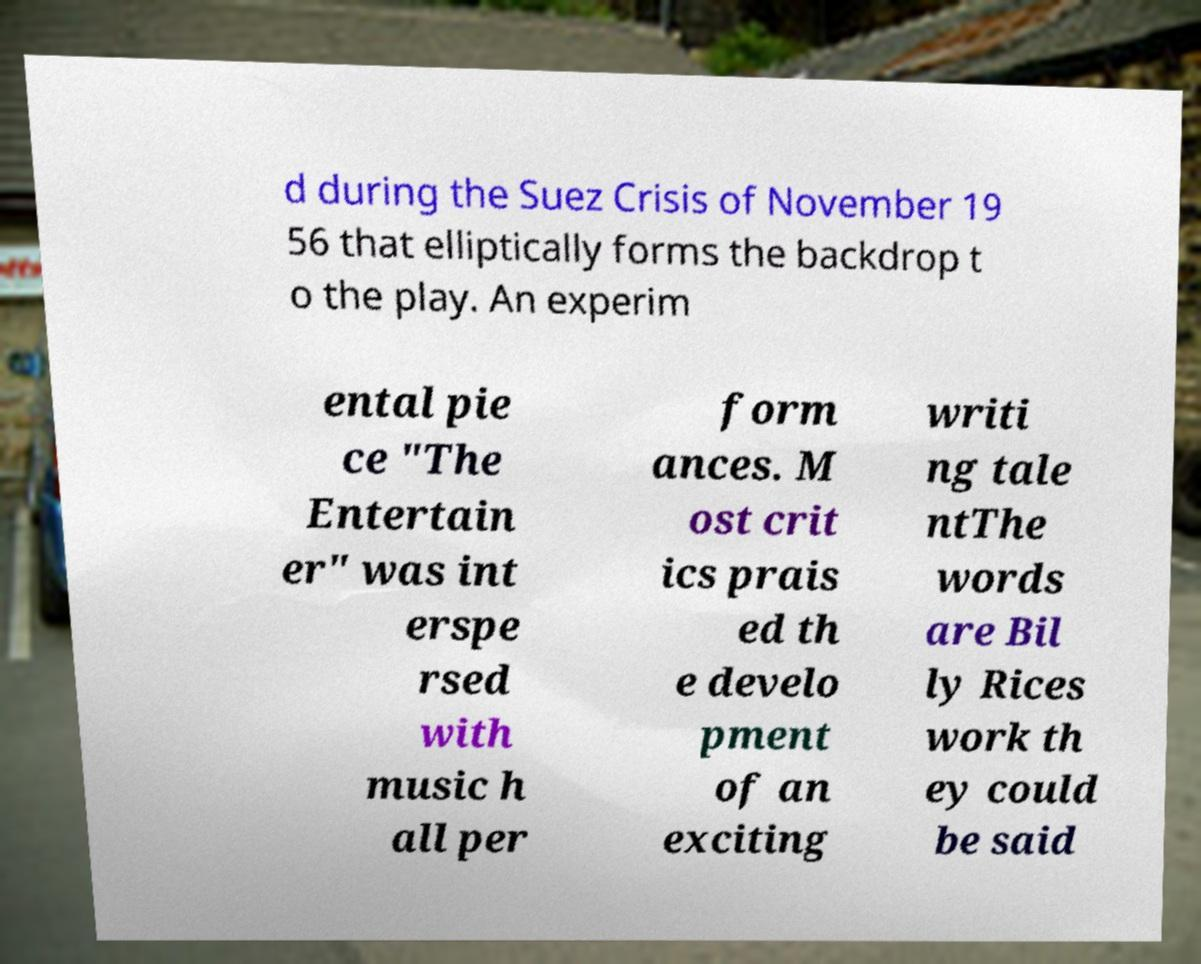What messages or text are displayed in this image? I need them in a readable, typed format. d during the Suez Crisis of November 19 56 that elliptically forms the backdrop t o the play. An experim ental pie ce "The Entertain er" was int erspe rsed with music h all per form ances. M ost crit ics prais ed th e develo pment of an exciting writi ng tale ntThe words are Bil ly Rices work th ey could be said 